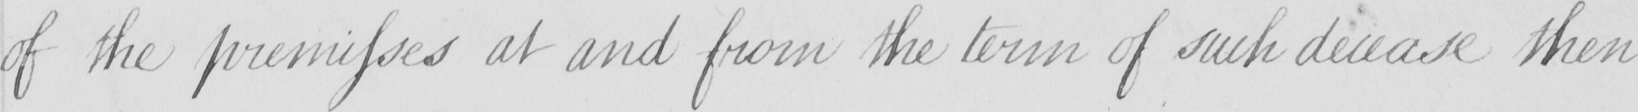What does this handwritten line say? of the premisses at and from the term of such decease then 